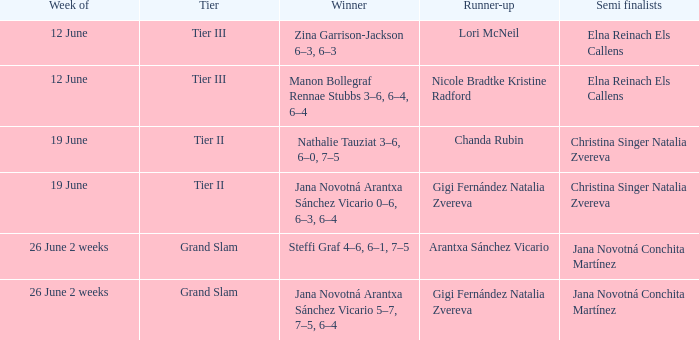In which week is the winner listed as Jana Novotná Arantxa Sánchez Vicario 5–7, 7–5, 6–4? 26 June 2 weeks. 